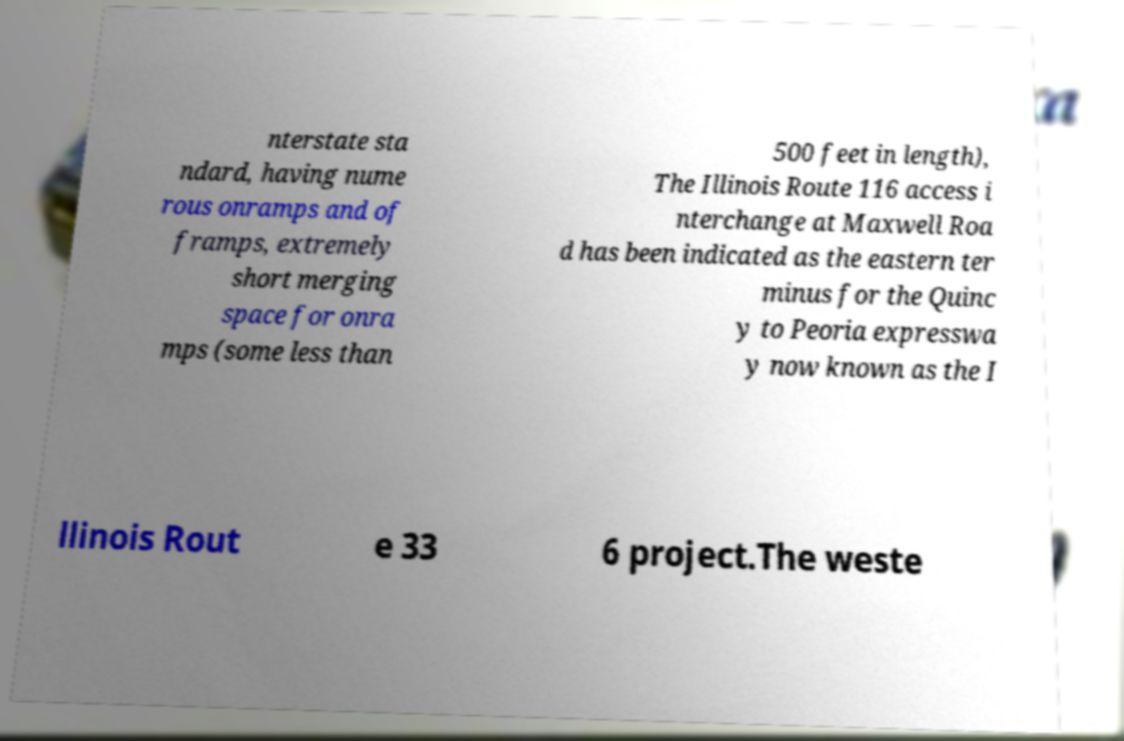What messages or text are displayed in this image? I need them in a readable, typed format. nterstate sta ndard, having nume rous onramps and of framps, extremely short merging space for onra mps (some less than 500 feet in length), The Illinois Route 116 access i nterchange at Maxwell Roa d has been indicated as the eastern ter minus for the Quinc y to Peoria expresswa y now known as the I llinois Rout e 33 6 project.The weste 